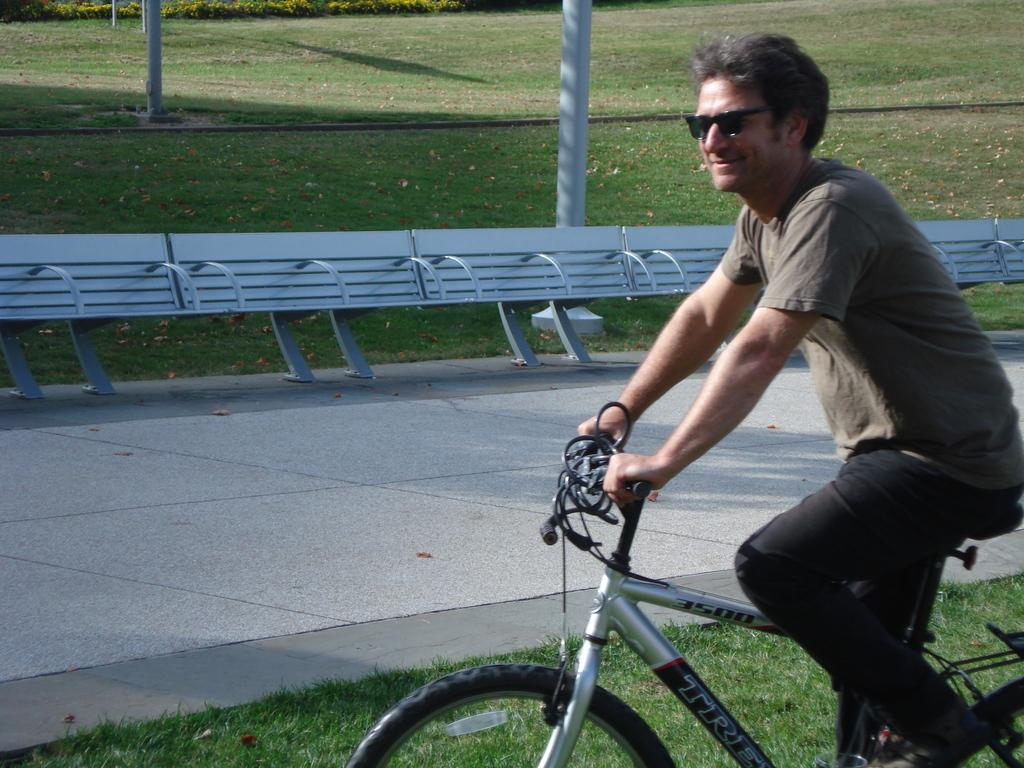What is the main subject of the image? The main subject of the image is a man. What is the man doing in the image? The man is riding a bicycle. What is the man's facial expression in the image? The man is smiling. What type of doll is the man holding while riding the bicycle in the image? There is no doll present in the image; the man is riding a bicycle and smiling. 